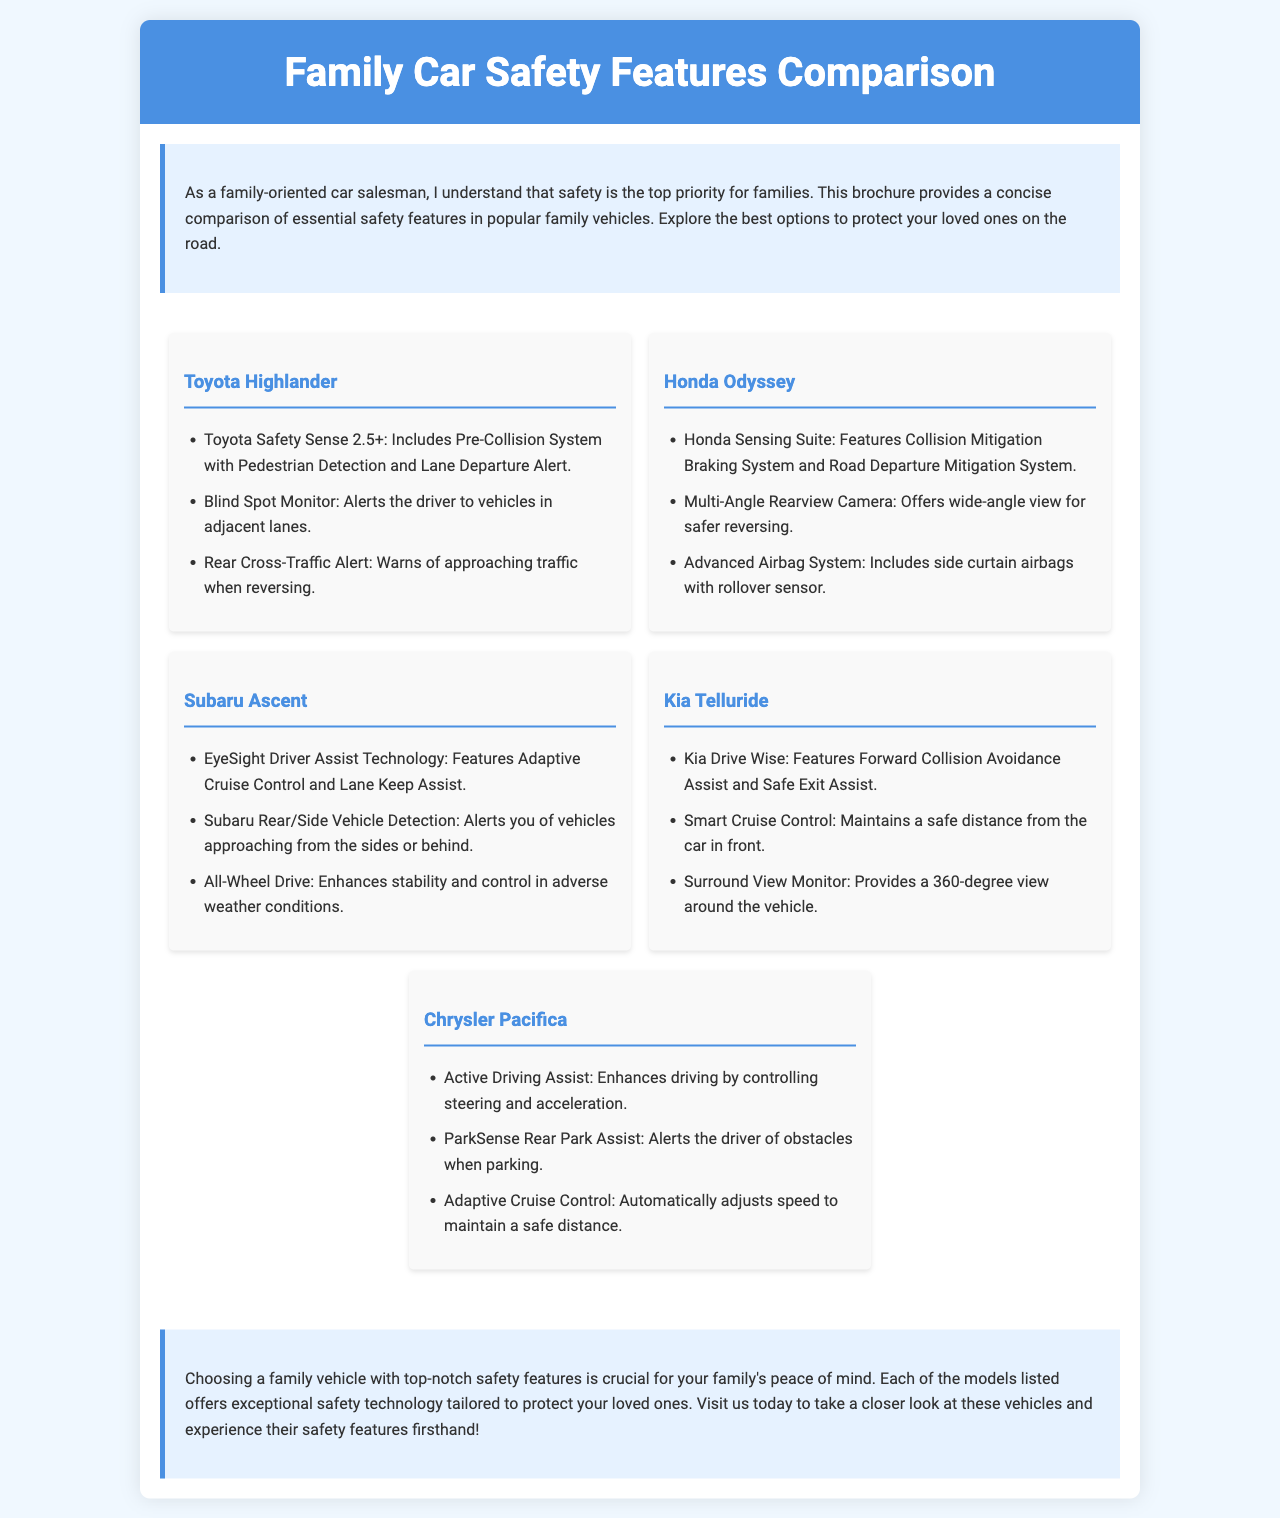What is the title of the brochure? The title of the brochure is clearly stated in the header section.
Answer: Family Car Safety Features Comparison Which vehicle features Toyota Safety Sense 2.5+? This safety feature is listed under the Toyota Highlander section.
Answer: Toyota Highlander What technology does the Honda Odyssey include for collision mitigation? The document lists the specific safety technology included in the Honda Odyssey.
Answer: Collision Mitigation Braking System What feature of the Subaru Ascent enhances stability in adverse weather? This is mentioned in the safety features of the Subaru Ascent.
Answer: All-Wheel Drive Which vehicle offers a Surround View Monitor? This feature is specifically listed for the Kia Telluride.
Answer: Kia Telluride What is the purpose of the ParkSense Rear Park Assist? The document describes the purpose of this feature under the Chrysler Pacifica section.
Answer: Alerts the driver of obstacles when parking Which vehicle has Blind Spot Monitor as a safety feature? This safety feature is associated with the Toyota Highlander.
Answer: Toyota Highlander How many family vehicles are compared in the brochure? The total number of vehicles listed can be counted from the sections of the brochure.
Answer: Five 